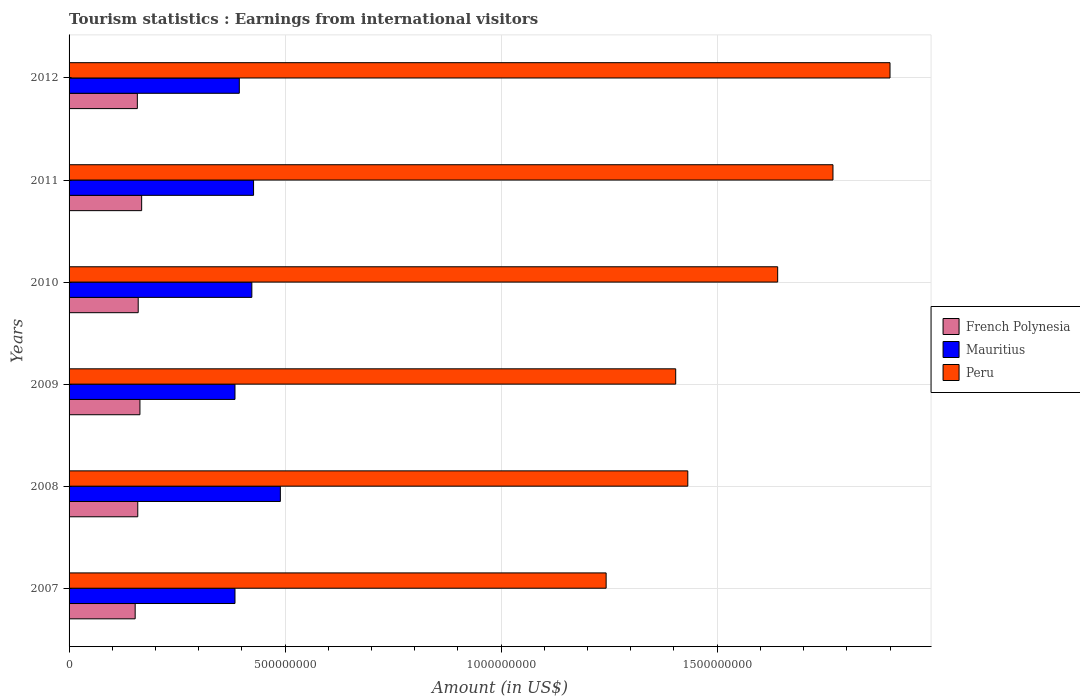Are the number of bars per tick equal to the number of legend labels?
Keep it short and to the point. Yes. How many bars are there on the 2nd tick from the top?
Your answer should be very brief. 3. How many bars are there on the 3rd tick from the bottom?
Keep it short and to the point. 3. In how many cases, is the number of bars for a given year not equal to the number of legend labels?
Provide a succinct answer. 0. What is the earnings from international visitors in French Polynesia in 2010?
Your response must be concise. 1.60e+08. Across all years, what is the maximum earnings from international visitors in French Polynesia?
Provide a succinct answer. 1.68e+08. Across all years, what is the minimum earnings from international visitors in Peru?
Offer a very short reply. 1.24e+09. In which year was the earnings from international visitors in Mauritius maximum?
Your response must be concise. 2008. In which year was the earnings from international visitors in French Polynesia minimum?
Ensure brevity in your answer.  2007. What is the total earnings from international visitors in Mauritius in the graph?
Provide a succinct answer. 2.50e+09. What is the difference between the earnings from international visitors in Mauritius in 2010 and that in 2012?
Your answer should be compact. 2.90e+07. What is the difference between the earnings from international visitors in Peru in 2008 and the earnings from international visitors in French Polynesia in 2007?
Provide a short and direct response. 1.28e+09. What is the average earnings from international visitors in Mauritius per year?
Your response must be concise. 4.17e+08. In the year 2012, what is the difference between the earnings from international visitors in Mauritius and earnings from international visitors in French Polynesia?
Provide a succinct answer. 2.36e+08. In how many years, is the earnings from international visitors in French Polynesia greater than 1100000000 US$?
Provide a succinct answer. 0. What is the ratio of the earnings from international visitors in French Polynesia in 2007 to that in 2009?
Your response must be concise. 0.93. Is the earnings from international visitors in Peru in 2008 less than that in 2011?
Your response must be concise. Yes. What is the difference between the highest and the lowest earnings from international visitors in Peru?
Your response must be concise. 6.57e+08. In how many years, is the earnings from international visitors in Peru greater than the average earnings from international visitors in Peru taken over all years?
Your answer should be compact. 3. Is the sum of the earnings from international visitors in French Polynesia in 2007 and 2010 greater than the maximum earnings from international visitors in Peru across all years?
Provide a succinct answer. No. What does the 2nd bar from the bottom in 2010 represents?
Give a very brief answer. Mauritius. What is the difference between two consecutive major ticks on the X-axis?
Ensure brevity in your answer.  5.00e+08. Are the values on the major ticks of X-axis written in scientific E-notation?
Provide a short and direct response. No. Does the graph contain grids?
Give a very brief answer. Yes. Where does the legend appear in the graph?
Provide a succinct answer. Center right. How many legend labels are there?
Your answer should be very brief. 3. How are the legend labels stacked?
Keep it short and to the point. Vertical. What is the title of the graph?
Ensure brevity in your answer.  Tourism statistics : Earnings from international visitors. Does "High income: OECD" appear as one of the legend labels in the graph?
Give a very brief answer. No. What is the label or title of the Y-axis?
Provide a short and direct response. Years. What is the Amount (in US$) in French Polynesia in 2007?
Provide a short and direct response. 1.53e+08. What is the Amount (in US$) in Mauritius in 2007?
Provide a succinct answer. 3.84e+08. What is the Amount (in US$) in Peru in 2007?
Ensure brevity in your answer.  1.24e+09. What is the Amount (in US$) of French Polynesia in 2008?
Ensure brevity in your answer.  1.59e+08. What is the Amount (in US$) of Mauritius in 2008?
Give a very brief answer. 4.89e+08. What is the Amount (in US$) in Peru in 2008?
Your response must be concise. 1.43e+09. What is the Amount (in US$) in French Polynesia in 2009?
Offer a terse response. 1.64e+08. What is the Amount (in US$) in Mauritius in 2009?
Provide a succinct answer. 3.84e+08. What is the Amount (in US$) in Peru in 2009?
Provide a succinct answer. 1.40e+09. What is the Amount (in US$) in French Polynesia in 2010?
Your answer should be very brief. 1.60e+08. What is the Amount (in US$) of Mauritius in 2010?
Your answer should be very brief. 4.23e+08. What is the Amount (in US$) in Peru in 2010?
Ensure brevity in your answer.  1.64e+09. What is the Amount (in US$) in French Polynesia in 2011?
Make the answer very short. 1.68e+08. What is the Amount (in US$) in Mauritius in 2011?
Offer a very short reply. 4.27e+08. What is the Amount (in US$) in Peru in 2011?
Offer a terse response. 1.77e+09. What is the Amount (in US$) in French Polynesia in 2012?
Give a very brief answer. 1.58e+08. What is the Amount (in US$) of Mauritius in 2012?
Offer a very short reply. 3.94e+08. What is the Amount (in US$) of Peru in 2012?
Your response must be concise. 1.90e+09. Across all years, what is the maximum Amount (in US$) of French Polynesia?
Make the answer very short. 1.68e+08. Across all years, what is the maximum Amount (in US$) in Mauritius?
Your answer should be compact. 4.89e+08. Across all years, what is the maximum Amount (in US$) of Peru?
Your answer should be very brief. 1.90e+09. Across all years, what is the minimum Amount (in US$) of French Polynesia?
Offer a very short reply. 1.53e+08. Across all years, what is the minimum Amount (in US$) in Mauritius?
Your response must be concise. 3.84e+08. Across all years, what is the minimum Amount (in US$) in Peru?
Make the answer very short. 1.24e+09. What is the total Amount (in US$) in French Polynesia in the graph?
Offer a terse response. 9.62e+08. What is the total Amount (in US$) in Mauritius in the graph?
Offer a very short reply. 2.50e+09. What is the total Amount (in US$) in Peru in the graph?
Offer a terse response. 9.39e+09. What is the difference between the Amount (in US$) in French Polynesia in 2007 and that in 2008?
Offer a very short reply. -6.00e+06. What is the difference between the Amount (in US$) of Mauritius in 2007 and that in 2008?
Your response must be concise. -1.05e+08. What is the difference between the Amount (in US$) of Peru in 2007 and that in 2008?
Give a very brief answer. -1.89e+08. What is the difference between the Amount (in US$) of French Polynesia in 2007 and that in 2009?
Make the answer very short. -1.10e+07. What is the difference between the Amount (in US$) in Mauritius in 2007 and that in 2009?
Your answer should be compact. 0. What is the difference between the Amount (in US$) of Peru in 2007 and that in 2009?
Ensure brevity in your answer.  -1.61e+08. What is the difference between the Amount (in US$) in French Polynesia in 2007 and that in 2010?
Keep it short and to the point. -7.00e+06. What is the difference between the Amount (in US$) in Mauritius in 2007 and that in 2010?
Offer a very short reply. -3.90e+07. What is the difference between the Amount (in US$) of Peru in 2007 and that in 2010?
Give a very brief answer. -3.97e+08. What is the difference between the Amount (in US$) of French Polynesia in 2007 and that in 2011?
Provide a succinct answer. -1.50e+07. What is the difference between the Amount (in US$) of Mauritius in 2007 and that in 2011?
Your response must be concise. -4.30e+07. What is the difference between the Amount (in US$) of Peru in 2007 and that in 2011?
Keep it short and to the point. -5.25e+08. What is the difference between the Amount (in US$) in French Polynesia in 2007 and that in 2012?
Offer a terse response. -5.00e+06. What is the difference between the Amount (in US$) in Mauritius in 2007 and that in 2012?
Provide a succinct answer. -1.00e+07. What is the difference between the Amount (in US$) in Peru in 2007 and that in 2012?
Offer a very short reply. -6.57e+08. What is the difference between the Amount (in US$) of French Polynesia in 2008 and that in 2009?
Provide a succinct answer. -5.00e+06. What is the difference between the Amount (in US$) in Mauritius in 2008 and that in 2009?
Give a very brief answer. 1.05e+08. What is the difference between the Amount (in US$) of Peru in 2008 and that in 2009?
Offer a very short reply. 2.80e+07. What is the difference between the Amount (in US$) in Mauritius in 2008 and that in 2010?
Make the answer very short. 6.60e+07. What is the difference between the Amount (in US$) in Peru in 2008 and that in 2010?
Your response must be concise. -2.08e+08. What is the difference between the Amount (in US$) in French Polynesia in 2008 and that in 2011?
Ensure brevity in your answer.  -9.00e+06. What is the difference between the Amount (in US$) of Mauritius in 2008 and that in 2011?
Offer a very short reply. 6.20e+07. What is the difference between the Amount (in US$) in Peru in 2008 and that in 2011?
Offer a very short reply. -3.36e+08. What is the difference between the Amount (in US$) in French Polynesia in 2008 and that in 2012?
Offer a terse response. 1.00e+06. What is the difference between the Amount (in US$) in Mauritius in 2008 and that in 2012?
Offer a very short reply. 9.50e+07. What is the difference between the Amount (in US$) in Peru in 2008 and that in 2012?
Offer a terse response. -4.68e+08. What is the difference between the Amount (in US$) of French Polynesia in 2009 and that in 2010?
Make the answer very short. 4.00e+06. What is the difference between the Amount (in US$) of Mauritius in 2009 and that in 2010?
Give a very brief answer. -3.90e+07. What is the difference between the Amount (in US$) in Peru in 2009 and that in 2010?
Provide a succinct answer. -2.36e+08. What is the difference between the Amount (in US$) of Mauritius in 2009 and that in 2011?
Your answer should be very brief. -4.30e+07. What is the difference between the Amount (in US$) of Peru in 2009 and that in 2011?
Your response must be concise. -3.64e+08. What is the difference between the Amount (in US$) in French Polynesia in 2009 and that in 2012?
Offer a very short reply. 6.00e+06. What is the difference between the Amount (in US$) in Mauritius in 2009 and that in 2012?
Give a very brief answer. -1.00e+07. What is the difference between the Amount (in US$) in Peru in 2009 and that in 2012?
Make the answer very short. -4.96e+08. What is the difference between the Amount (in US$) in French Polynesia in 2010 and that in 2011?
Keep it short and to the point. -8.00e+06. What is the difference between the Amount (in US$) in Mauritius in 2010 and that in 2011?
Ensure brevity in your answer.  -4.00e+06. What is the difference between the Amount (in US$) in Peru in 2010 and that in 2011?
Provide a succinct answer. -1.28e+08. What is the difference between the Amount (in US$) in French Polynesia in 2010 and that in 2012?
Your response must be concise. 2.00e+06. What is the difference between the Amount (in US$) of Mauritius in 2010 and that in 2012?
Your answer should be compact. 2.90e+07. What is the difference between the Amount (in US$) in Peru in 2010 and that in 2012?
Provide a short and direct response. -2.60e+08. What is the difference between the Amount (in US$) in French Polynesia in 2011 and that in 2012?
Your answer should be compact. 1.00e+07. What is the difference between the Amount (in US$) of Mauritius in 2011 and that in 2012?
Your answer should be very brief. 3.30e+07. What is the difference between the Amount (in US$) in Peru in 2011 and that in 2012?
Provide a succinct answer. -1.32e+08. What is the difference between the Amount (in US$) in French Polynesia in 2007 and the Amount (in US$) in Mauritius in 2008?
Your answer should be very brief. -3.36e+08. What is the difference between the Amount (in US$) of French Polynesia in 2007 and the Amount (in US$) of Peru in 2008?
Keep it short and to the point. -1.28e+09. What is the difference between the Amount (in US$) of Mauritius in 2007 and the Amount (in US$) of Peru in 2008?
Ensure brevity in your answer.  -1.05e+09. What is the difference between the Amount (in US$) of French Polynesia in 2007 and the Amount (in US$) of Mauritius in 2009?
Give a very brief answer. -2.31e+08. What is the difference between the Amount (in US$) in French Polynesia in 2007 and the Amount (in US$) in Peru in 2009?
Make the answer very short. -1.25e+09. What is the difference between the Amount (in US$) of Mauritius in 2007 and the Amount (in US$) of Peru in 2009?
Offer a very short reply. -1.02e+09. What is the difference between the Amount (in US$) of French Polynesia in 2007 and the Amount (in US$) of Mauritius in 2010?
Your answer should be compact. -2.70e+08. What is the difference between the Amount (in US$) of French Polynesia in 2007 and the Amount (in US$) of Peru in 2010?
Ensure brevity in your answer.  -1.49e+09. What is the difference between the Amount (in US$) in Mauritius in 2007 and the Amount (in US$) in Peru in 2010?
Keep it short and to the point. -1.26e+09. What is the difference between the Amount (in US$) of French Polynesia in 2007 and the Amount (in US$) of Mauritius in 2011?
Keep it short and to the point. -2.74e+08. What is the difference between the Amount (in US$) of French Polynesia in 2007 and the Amount (in US$) of Peru in 2011?
Give a very brief answer. -1.62e+09. What is the difference between the Amount (in US$) in Mauritius in 2007 and the Amount (in US$) in Peru in 2011?
Your answer should be very brief. -1.38e+09. What is the difference between the Amount (in US$) of French Polynesia in 2007 and the Amount (in US$) of Mauritius in 2012?
Keep it short and to the point. -2.41e+08. What is the difference between the Amount (in US$) in French Polynesia in 2007 and the Amount (in US$) in Peru in 2012?
Your answer should be compact. -1.75e+09. What is the difference between the Amount (in US$) in Mauritius in 2007 and the Amount (in US$) in Peru in 2012?
Give a very brief answer. -1.52e+09. What is the difference between the Amount (in US$) in French Polynesia in 2008 and the Amount (in US$) in Mauritius in 2009?
Give a very brief answer. -2.25e+08. What is the difference between the Amount (in US$) of French Polynesia in 2008 and the Amount (in US$) of Peru in 2009?
Your response must be concise. -1.24e+09. What is the difference between the Amount (in US$) in Mauritius in 2008 and the Amount (in US$) in Peru in 2009?
Keep it short and to the point. -9.15e+08. What is the difference between the Amount (in US$) of French Polynesia in 2008 and the Amount (in US$) of Mauritius in 2010?
Provide a succinct answer. -2.64e+08. What is the difference between the Amount (in US$) of French Polynesia in 2008 and the Amount (in US$) of Peru in 2010?
Your response must be concise. -1.48e+09. What is the difference between the Amount (in US$) of Mauritius in 2008 and the Amount (in US$) of Peru in 2010?
Offer a terse response. -1.15e+09. What is the difference between the Amount (in US$) of French Polynesia in 2008 and the Amount (in US$) of Mauritius in 2011?
Provide a succinct answer. -2.68e+08. What is the difference between the Amount (in US$) in French Polynesia in 2008 and the Amount (in US$) in Peru in 2011?
Offer a terse response. -1.61e+09. What is the difference between the Amount (in US$) in Mauritius in 2008 and the Amount (in US$) in Peru in 2011?
Offer a terse response. -1.28e+09. What is the difference between the Amount (in US$) in French Polynesia in 2008 and the Amount (in US$) in Mauritius in 2012?
Your answer should be compact. -2.35e+08. What is the difference between the Amount (in US$) in French Polynesia in 2008 and the Amount (in US$) in Peru in 2012?
Your answer should be compact. -1.74e+09. What is the difference between the Amount (in US$) in Mauritius in 2008 and the Amount (in US$) in Peru in 2012?
Offer a very short reply. -1.41e+09. What is the difference between the Amount (in US$) of French Polynesia in 2009 and the Amount (in US$) of Mauritius in 2010?
Offer a very short reply. -2.59e+08. What is the difference between the Amount (in US$) of French Polynesia in 2009 and the Amount (in US$) of Peru in 2010?
Offer a terse response. -1.48e+09. What is the difference between the Amount (in US$) in Mauritius in 2009 and the Amount (in US$) in Peru in 2010?
Offer a very short reply. -1.26e+09. What is the difference between the Amount (in US$) in French Polynesia in 2009 and the Amount (in US$) in Mauritius in 2011?
Your response must be concise. -2.63e+08. What is the difference between the Amount (in US$) of French Polynesia in 2009 and the Amount (in US$) of Peru in 2011?
Your answer should be very brief. -1.60e+09. What is the difference between the Amount (in US$) of Mauritius in 2009 and the Amount (in US$) of Peru in 2011?
Offer a very short reply. -1.38e+09. What is the difference between the Amount (in US$) in French Polynesia in 2009 and the Amount (in US$) in Mauritius in 2012?
Keep it short and to the point. -2.30e+08. What is the difference between the Amount (in US$) in French Polynesia in 2009 and the Amount (in US$) in Peru in 2012?
Your answer should be very brief. -1.74e+09. What is the difference between the Amount (in US$) in Mauritius in 2009 and the Amount (in US$) in Peru in 2012?
Offer a very short reply. -1.52e+09. What is the difference between the Amount (in US$) in French Polynesia in 2010 and the Amount (in US$) in Mauritius in 2011?
Your answer should be very brief. -2.67e+08. What is the difference between the Amount (in US$) of French Polynesia in 2010 and the Amount (in US$) of Peru in 2011?
Provide a succinct answer. -1.61e+09. What is the difference between the Amount (in US$) in Mauritius in 2010 and the Amount (in US$) in Peru in 2011?
Make the answer very short. -1.34e+09. What is the difference between the Amount (in US$) of French Polynesia in 2010 and the Amount (in US$) of Mauritius in 2012?
Your answer should be very brief. -2.34e+08. What is the difference between the Amount (in US$) of French Polynesia in 2010 and the Amount (in US$) of Peru in 2012?
Offer a terse response. -1.74e+09. What is the difference between the Amount (in US$) of Mauritius in 2010 and the Amount (in US$) of Peru in 2012?
Give a very brief answer. -1.48e+09. What is the difference between the Amount (in US$) in French Polynesia in 2011 and the Amount (in US$) in Mauritius in 2012?
Keep it short and to the point. -2.26e+08. What is the difference between the Amount (in US$) in French Polynesia in 2011 and the Amount (in US$) in Peru in 2012?
Offer a very short reply. -1.73e+09. What is the difference between the Amount (in US$) in Mauritius in 2011 and the Amount (in US$) in Peru in 2012?
Offer a terse response. -1.47e+09. What is the average Amount (in US$) in French Polynesia per year?
Give a very brief answer. 1.60e+08. What is the average Amount (in US$) in Mauritius per year?
Give a very brief answer. 4.17e+08. What is the average Amount (in US$) in Peru per year?
Provide a short and direct response. 1.56e+09. In the year 2007, what is the difference between the Amount (in US$) of French Polynesia and Amount (in US$) of Mauritius?
Keep it short and to the point. -2.31e+08. In the year 2007, what is the difference between the Amount (in US$) in French Polynesia and Amount (in US$) in Peru?
Provide a succinct answer. -1.09e+09. In the year 2007, what is the difference between the Amount (in US$) of Mauritius and Amount (in US$) of Peru?
Keep it short and to the point. -8.59e+08. In the year 2008, what is the difference between the Amount (in US$) in French Polynesia and Amount (in US$) in Mauritius?
Offer a very short reply. -3.30e+08. In the year 2008, what is the difference between the Amount (in US$) in French Polynesia and Amount (in US$) in Peru?
Make the answer very short. -1.27e+09. In the year 2008, what is the difference between the Amount (in US$) of Mauritius and Amount (in US$) of Peru?
Your answer should be compact. -9.43e+08. In the year 2009, what is the difference between the Amount (in US$) of French Polynesia and Amount (in US$) of Mauritius?
Offer a very short reply. -2.20e+08. In the year 2009, what is the difference between the Amount (in US$) of French Polynesia and Amount (in US$) of Peru?
Your answer should be compact. -1.24e+09. In the year 2009, what is the difference between the Amount (in US$) in Mauritius and Amount (in US$) in Peru?
Provide a short and direct response. -1.02e+09. In the year 2010, what is the difference between the Amount (in US$) in French Polynesia and Amount (in US$) in Mauritius?
Give a very brief answer. -2.63e+08. In the year 2010, what is the difference between the Amount (in US$) of French Polynesia and Amount (in US$) of Peru?
Give a very brief answer. -1.48e+09. In the year 2010, what is the difference between the Amount (in US$) in Mauritius and Amount (in US$) in Peru?
Offer a very short reply. -1.22e+09. In the year 2011, what is the difference between the Amount (in US$) in French Polynesia and Amount (in US$) in Mauritius?
Offer a terse response. -2.59e+08. In the year 2011, what is the difference between the Amount (in US$) of French Polynesia and Amount (in US$) of Peru?
Offer a terse response. -1.60e+09. In the year 2011, what is the difference between the Amount (in US$) of Mauritius and Amount (in US$) of Peru?
Offer a terse response. -1.34e+09. In the year 2012, what is the difference between the Amount (in US$) in French Polynesia and Amount (in US$) in Mauritius?
Make the answer very short. -2.36e+08. In the year 2012, what is the difference between the Amount (in US$) of French Polynesia and Amount (in US$) of Peru?
Offer a very short reply. -1.74e+09. In the year 2012, what is the difference between the Amount (in US$) of Mauritius and Amount (in US$) of Peru?
Offer a very short reply. -1.51e+09. What is the ratio of the Amount (in US$) in French Polynesia in 2007 to that in 2008?
Provide a short and direct response. 0.96. What is the ratio of the Amount (in US$) of Mauritius in 2007 to that in 2008?
Give a very brief answer. 0.79. What is the ratio of the Amount (in US$) of Peru in 2007 to that in 2008?
Make the answer very short. 0.87. What is the ratio of the Amount (in US$) of French Polynesia in 2007 to that in 2009?
Offer a very short reply. 0.93. What is the ratio of the Amount (in US$) in Peru in 2007 to that in 2009?
Give a very brief answer. 0.89. What is the ratio of the Amount (in US$) in French Polynesia in 2007 to that in 2010?
Offer a terse response. 0.96. What is the ratio of the Amount (in US$) in Mauritius in 2007 to that in 2010?
Provide a succinct answer. 0.91. What is the ratio of the Amount (in US$) in Peru in 2007 to that in 2010?
Offer a very short reply. 0.76. What is the ratio of the Amount (in US$) in French Polynesia in 2007 to that in 2011?
Keep it short and to the point. 0.91. What is the ratio of the Amount (in US$) of Mauritius in 2007 to that in 2011?
Offer a terse response. 0.9. What is the ratio of the Amount (in US$) in Peru in 2007 to that in 2011?
Provide a short and direct response. 0.7. What is the ratio of the Amount (in US$) of French Polynesia in 2007 to that in 2012?
Offer a terse response. 0.97. What is the ratio of the Amount (in US$) in Mauritius in 2007 to that in 2012?
Your answer should be very brief. 0.97. What is the ratio of the Amount (in US$) of Peru in 2007 to that in 2012?
Provide a short and direct response. 0.65. What is the ratio of the Amount (in US$) of French Polynesia in 2008 to that in 2009?
Ensure brevity in your answer.  0.97. What is the ratio of the Amount (in US$) of Mauritius in 2008 to that in 2009?
Give a very brief answer. 1.27. What is the ratio of the Amount (in US$) of Peru in 2008 to that in 2009?
Provide a succinct answer. 1.02. What is the ratio of the Amount (in US$) of French Polynesia in 2008 to that in 2010?
Give a very brief answer. 0.99. What is the ratio of the Amount (in US$) of Mauritius in 2008 to that in 2010?
Provide a succinct answer. 1.16. What is the ratio of the Amount (in US$) of Peru in 2008 to that in 2010?
Keep it short and to the point. 0.87. What is the ratio of the Amount (in US$) of French Polynesia in 2008 to that in 2011?
Make the answer very short. 0.95. What is the ratio of the Amount (in US$) in Mauritius in 2008 to that in 2011?
Offer a very short reply. 1.15. What is the ratio of the Amount (in US$) of Peru in 2008 to that in 2011?
Ensure brevity in your answer.  0.81. What is the ratio of the Amount (in US$) of French Polynesia in 2008 to that in 2012?
Keep it short and to the point. 1.01. What is the ratio of the Amount (in US$) of Mauritius in 2008 to that in 2012?
Your answer should be compact. 1.24. What is the ratio of the Amount (in US$) in Peru in 2008 to that in 2012?
Provide a succinct answer. 0.75. What is the ratio of the Amount (in US$) in Mauritius in 2009 to that in 2010?
Offer a terse response. 0.91. What is the ratio of the Amount (in US$) of Peru in 2009 to that in 2010?
Keep it short and to the point. 0.86. What is the ratio of the Amount (in US$) of French Polynesia in 2009 to that in 2011?
Give a very brief answer. 0.98. What is the ratio of the Amount (in US$) in Mauritius in 2009 to that in 2011?
Offer a terse response. 0.9. What is the ratio of the Amount (in US$) in Peru in 2009 to that in 2011?
Your response must be concise. 0.79. What is the ratio of the Amount (in US$) of French Polynesia in 2009 to that in 2012?
Offer a terse response. 1.04. What is the ratio of the Amount (in US$) of Mauritius in 2009 to that in 2012?
Your answer should be compact. 0.97. What is the ratio of the Amount (in US$) in Peru in 2009 to that in 2012?
Ensure brevity in your answer.  0.74. What is the ratio of the Amount (in US$) of French Polynesia in 2010 to that in 2011?
Your answer should be very brief. 0.95. What is the ratio of the Amount (in US$) in Mauritius in 2010 to that in 2011?
Give a very brief answer. 0.99. What is the ratio of the Amount (in US$) of Peru in 2010 to that in 2011?
Your answer should be very brief. 0.93. What is the ratio of the Amount (in US$) of French Polynesia in 2010 to that in 2012?
Provide a succinct answer. 1.01. What is the ratio of the Amount (in US$) of Mauritius in 2010 to that in 2012?
Make the answer very short. 1.07. What is the ratio of the Amount (in US$) of Peru in 2010 to that in 2012?
Your answer should be very brief. 0.86. What is the ratio of the Amount (in US$) of French Polynesia in 2011 to that in 2012?
Provide a short and direct response. 1.06. What is the ratio of the Amount (in US$) of Mauritius in 2011 to that in 2012?
Provide a short and direct response. 1.08. What is the ratio of the Amount (in US$) of Peru in 2011 to that in 2012?
Provide a short and direct response. 0.93. What is the difference between the highest and the second highest Amount (in US$) of French Polynesia?
Offer a very short reply. 4.00e+06. What is the difference between the highest and the second highest Amount (in US$) in Mauritius?
Provide a short and direct response. 6.20e+07. What is the difference between the highest and the second highest Amount (in US$) of Peru?
Offer a terse response. 1.32e+08. What is the difference between the highest and the lowest Amount (in US$) of French Polynesia?
Make the answer very short. 1.50e+07. What is the difference between the highest and the lowest Amount (in US$) in Mauritius?
Your answer should be compact. 1.05e+08. What is the difference between the highest and the lowest Amount (in US$) in Peru?
Your response must be concise. 6.57e+08. 